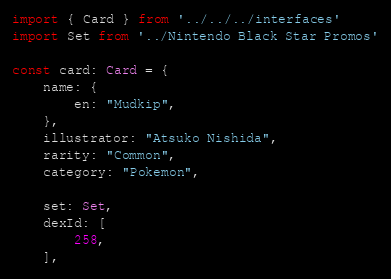Convert code to text. <code><loc_0><loc_0><loc_500><loc_500><_TypeScript_>import { Card } from '../../../interfaces'
import Set from '../Nintendo Black Star Promos'

const card: Card = {
	name: {
		en: "Mudkip",
	},
	illustrator: "Atsuko Nishida",
	rarity: "Common",
	category: "Pokemon",

	set: Set,
	dexId: [
		258,
	],</code> 